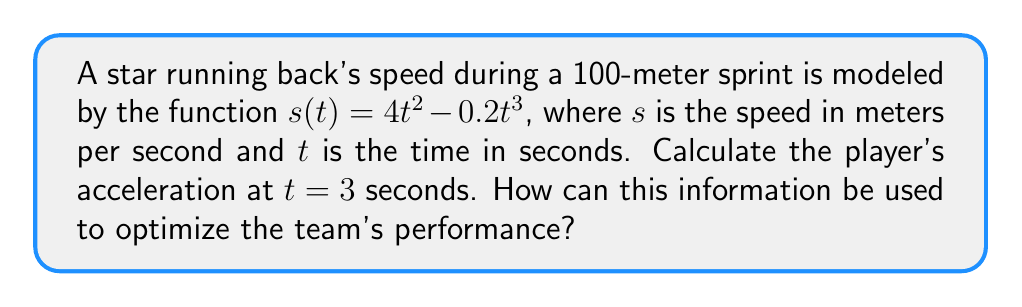Give your solution to this math problem. To find the player's acceleration at $t = 3$ seconds, we need to calculate the derivative of the speed function and evaluate it at $t = 3$.

Step 1: Find the derivative of $s(t)$.
$$\frac{d}{dt}s(t) = \frac{d}{dt}(4t^2 - 0.2t^3)$$
$$s'(t) = 8t - 0.6t^2$$

Step 2: Evaluate $s'(t)$ at $t = 3$.
$$s'(3) = 8(3) - 0.6(3)^2$$
$$s'(3) = 24 - 0.6(9)$$
$$s'(3) = 24 - 5.4$$
$$s'(3) = 18.6$$

The acceleration at $t = 3$ seconds is 18.6 m/s².

This information can be used to optimize the team's performance by:
1. Identifying peak acceleration points during sprints.
2. Designing training programs to improve acceleration at specific times.
3. Comparing players' acceleration profiles for strategic player selection.
4. Analyzing opponents' acceleration patterns for defensive planning.
Answer: 18.6 m/s² 